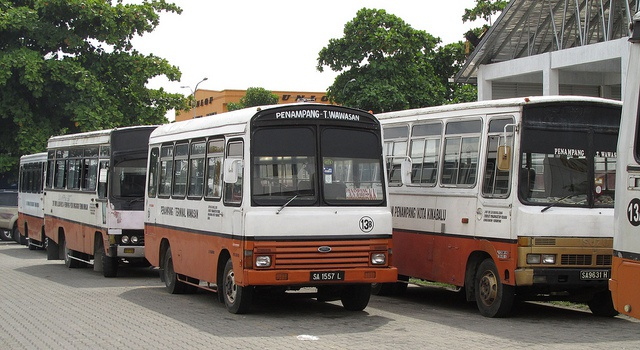Describe the objects in this image and their specific colors. I can see bus in green, black, darkgray, gray, and lightgray tones, bus in green, black, gray, lightgray, and darkgray tones, bus in green, black, gray, and darkgray tones, bus in green, darkgray, brown, black, and gray tones, and bus in green, black, darkgray, gray, and brown tones in this image. 